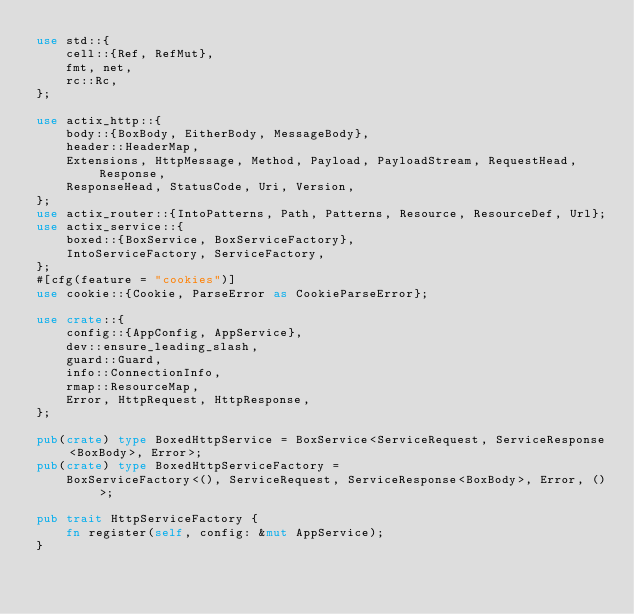<code> <loc_0><loc_0><loc_500><loc_500><_Rust_>use std::{
    cell::{Ref, RefMut},
    fmt, net,
    rc::Rc,
};

use actix_http::{
    body::{BoxBody, EitherBody, MessageBody},
    header::HeaderMap,
    Extensions, HttpMessage, Method, Payload, PayloadStream, RequestHead, Response,
    ResponseHead, StatusCode, Uri, Version,
};
use actix_router::{IntoPatterns, Path, Patterns, Resource, ResourceDef, Url};
use actix_service::{
    boxed::{BoxService, BoxServiceFactory},
    IntoServiceFactory, ServiceFactory,
};
#[cfg(feature = "cookies")]
use cookie::{Cookie, ParseError as CookieParseError};

use crate::{
    config::{AppConfig, AppService},
    dev::ensure_leading_slash,
    guard::Guard,
    info::ConnectionInfo,
    rmap::ResourceMap,
    Error, HttpRequest, HttpResponse,
};

pub(crate) type BoxedHttpService = BoxService<ServiceRequest, ServiceResponse<BoxBody>, Error>;
pub(crate) type BoxedHttpServiceFactory =
    BoxServiceFactory<(), ServiceRequest, ServiceResponse<BoxBody>, Error, ()>;

pub trait HttpServiceFactory {
    fn register(self, config: &mut AppService);
}
</code> 